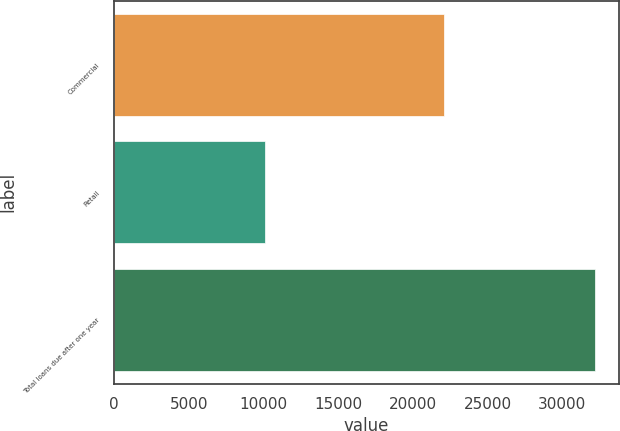<chart> <loc_0><loc_0><loc_500><loc_500><bar_chart><fcel>Commercial<fcel>Retail<fcel>Total loans due after one year<nl><fcel>22106<fcel>10073.8<fcel>32179.8<nl></chart> 